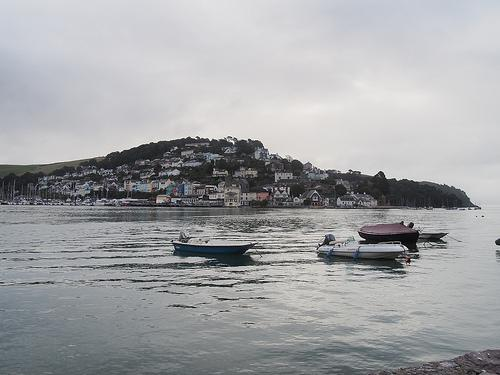Question: where are the boat?
Choices:
A. On the road.
B. In the sand.
C. In the air.
D. In the water.
Answer with the letter. Answer: D Question: who are in the boats?
Choices:
A. A lawyer.
B. No one.
C. A boy.
D. A banker.
Answer with the letter. Answer: B Question: what color are the boats?
Choices:
A. Black.
B. Yellow.
C. White, blue and red.
D. Orange.
Answer with the letter. Answer: C 